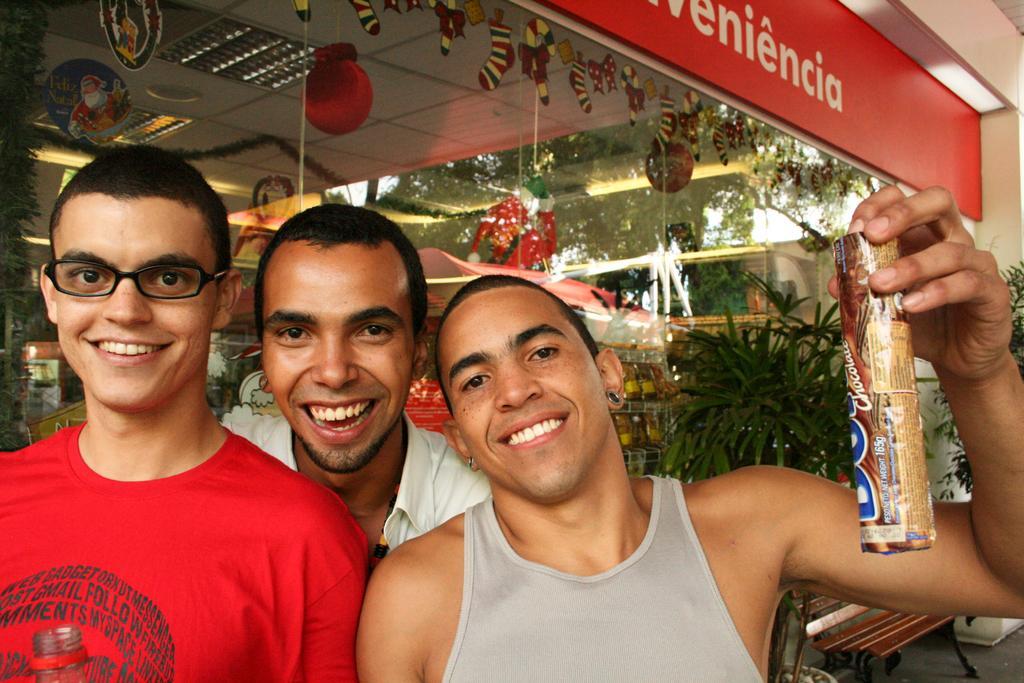Could you give a brief overview of what you see in this image? In this image a person wearing a red shirt is having spectacles. Behind him there is a person wearing a white shirt. Right side there is a person holding a chocolate in his hand. Behind him there is a plant. Beside to it there is a bench on the floor. Behind them there is a shop having few racks with objects in it. Few lights and decorative items are attached to the roof of the shop. 